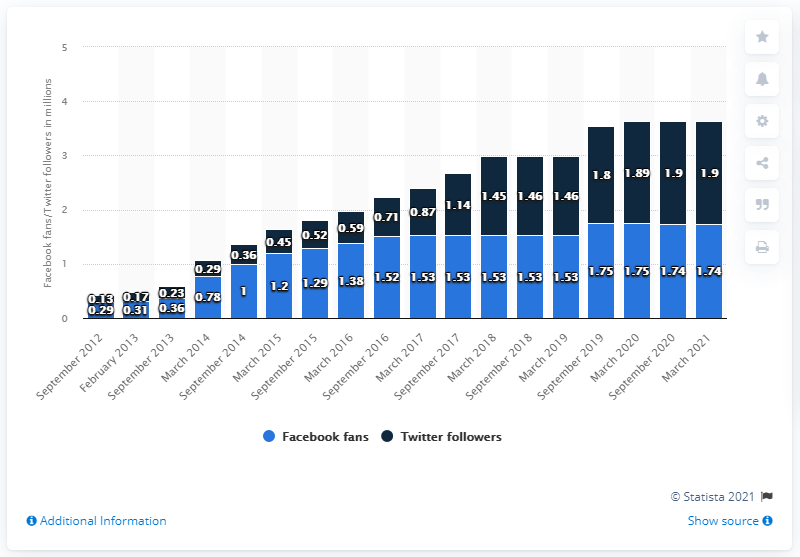Point out several critical features in this image. In March 2021, the Facebook page of the Philadelphia 76ers had approximately 1.74 million people engaged with the content. 